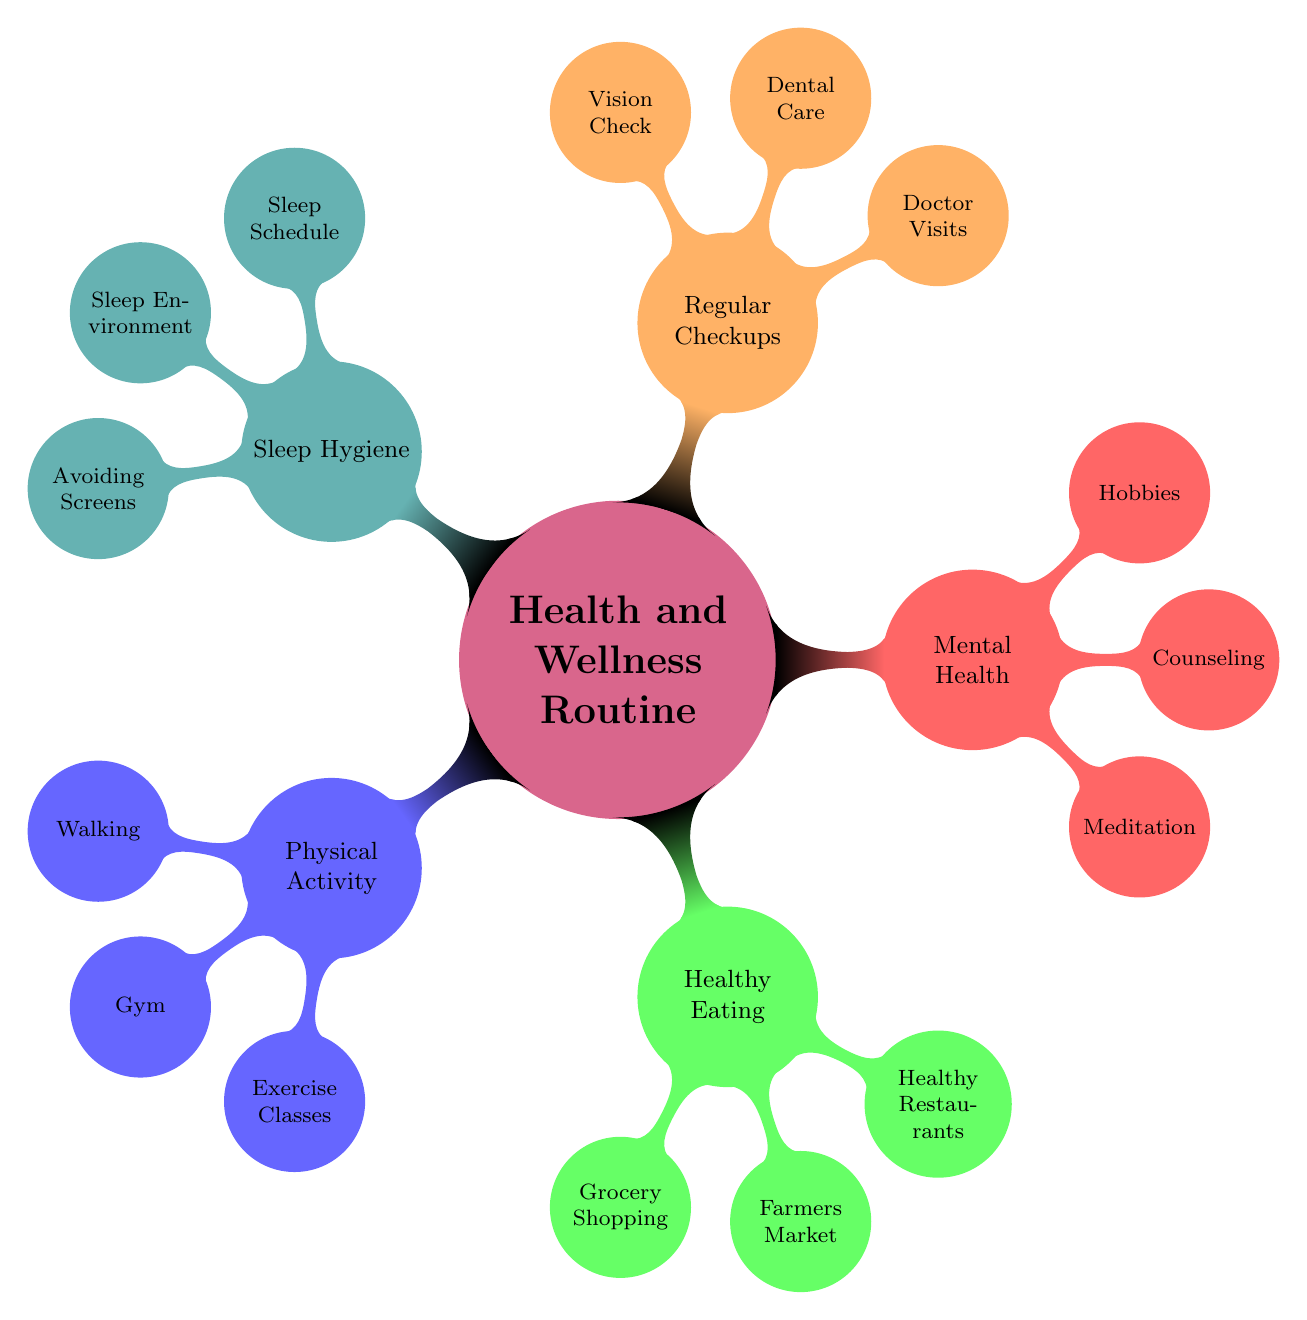What are the three branches of the Health and Wellness Routine? The diagram shows five main branches. However, focusing specifically on the request, the first three branches listed are Physical Activity, Healthy Eating, and Mental Health.
Answer: Physical Activity, Healthy Eating, Mental Health Where can you find Healthy Restaurants? The Healthy Restaurants node connects directly to the Healthy Eating branch, which indicates options for dining. The specific restaurant mentioned is The Root Cafe.
Answer: The Root Cafe How many activities are listed under Mental Health? The Mental Health category has three activities: Meditation, Counseling, and Hobbies. Counting these gives the total of three.
Answer: 3 Which grocery store is suggested for grocery shopping? The grocery shopping node in the Healthy Eating section links to Heinen's Grocery Store, indicating it is the suggested location.
Answer: Heinen's Grocery Store What is listed as a method to improve sleep hygiene? The Sleep Hygiene category includes three methods; one specific method mentioned is having a consistent bedtime routine, as outlined in the Sleep Schedule node.
Answer: Consistent bedtime routine Which location is associated with Exercise Classes? The Exercise Classes in the Physical Activity section are connected specifically to the YMCA Cleveland, indicated as the location for such classes.
Answer: YMCA Cleveland How many branches does the Health and Wellness Routine have? The diagram displays five main branches under the Health and Wellness Routine: Physical Activity, Healthy Eating, Mental Health, Regular Checkups, and Sleep Hygiene. Therefore, counting these provides the number of branches.
Answer: 5 What app is recommended for Meditation? The Meditation node under Mental Health connects to the Insight Timer App, which is indicated as the recommended tool for meditation practices.
Answer: Insight Timer App What type of store is America’s Best Contacts & Eyeglasses? In the Regular Checkups branch, America’s Best Contacts & Eyeglasses is categorized under Vision Check, indicating that it is a store for vision-related needs.
Answer: Vision-related store 